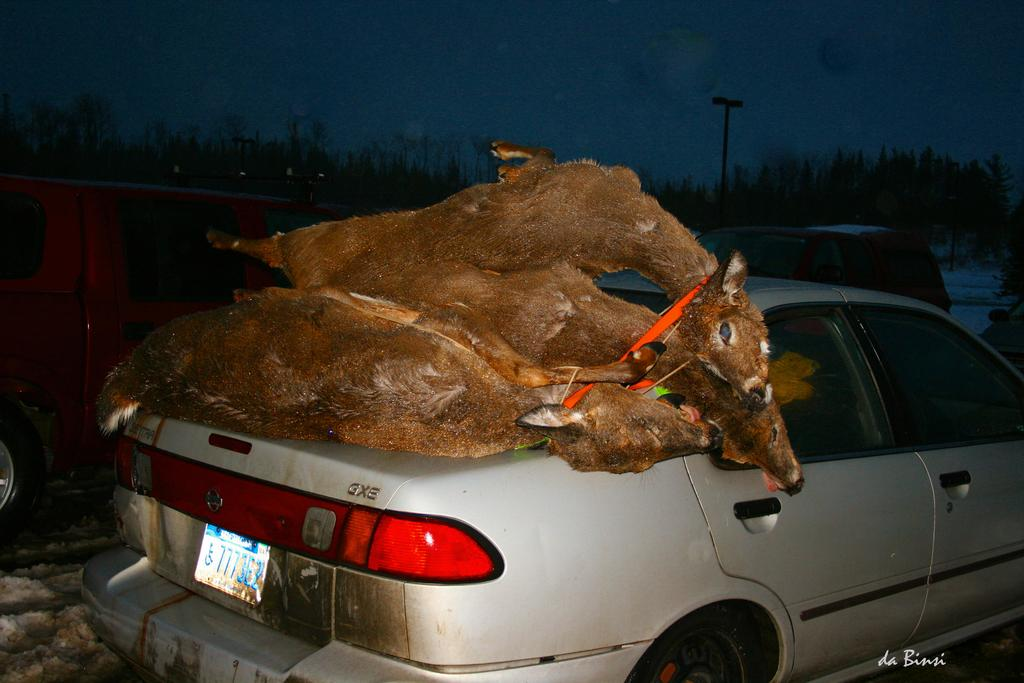What is the main subject of the image? The main subject of the image is a car. What is unusual about the car in the image? There are animals laying on the bumper of the car. What can be seen in the background of the image? There are trees around the car. What type of work is the car doing in the image? The car is not performing any work in the image; it is stationary with animals on its bumper. What force is being applied to the car by the animals? There is no indication of any force being applied by the animals in the image. 